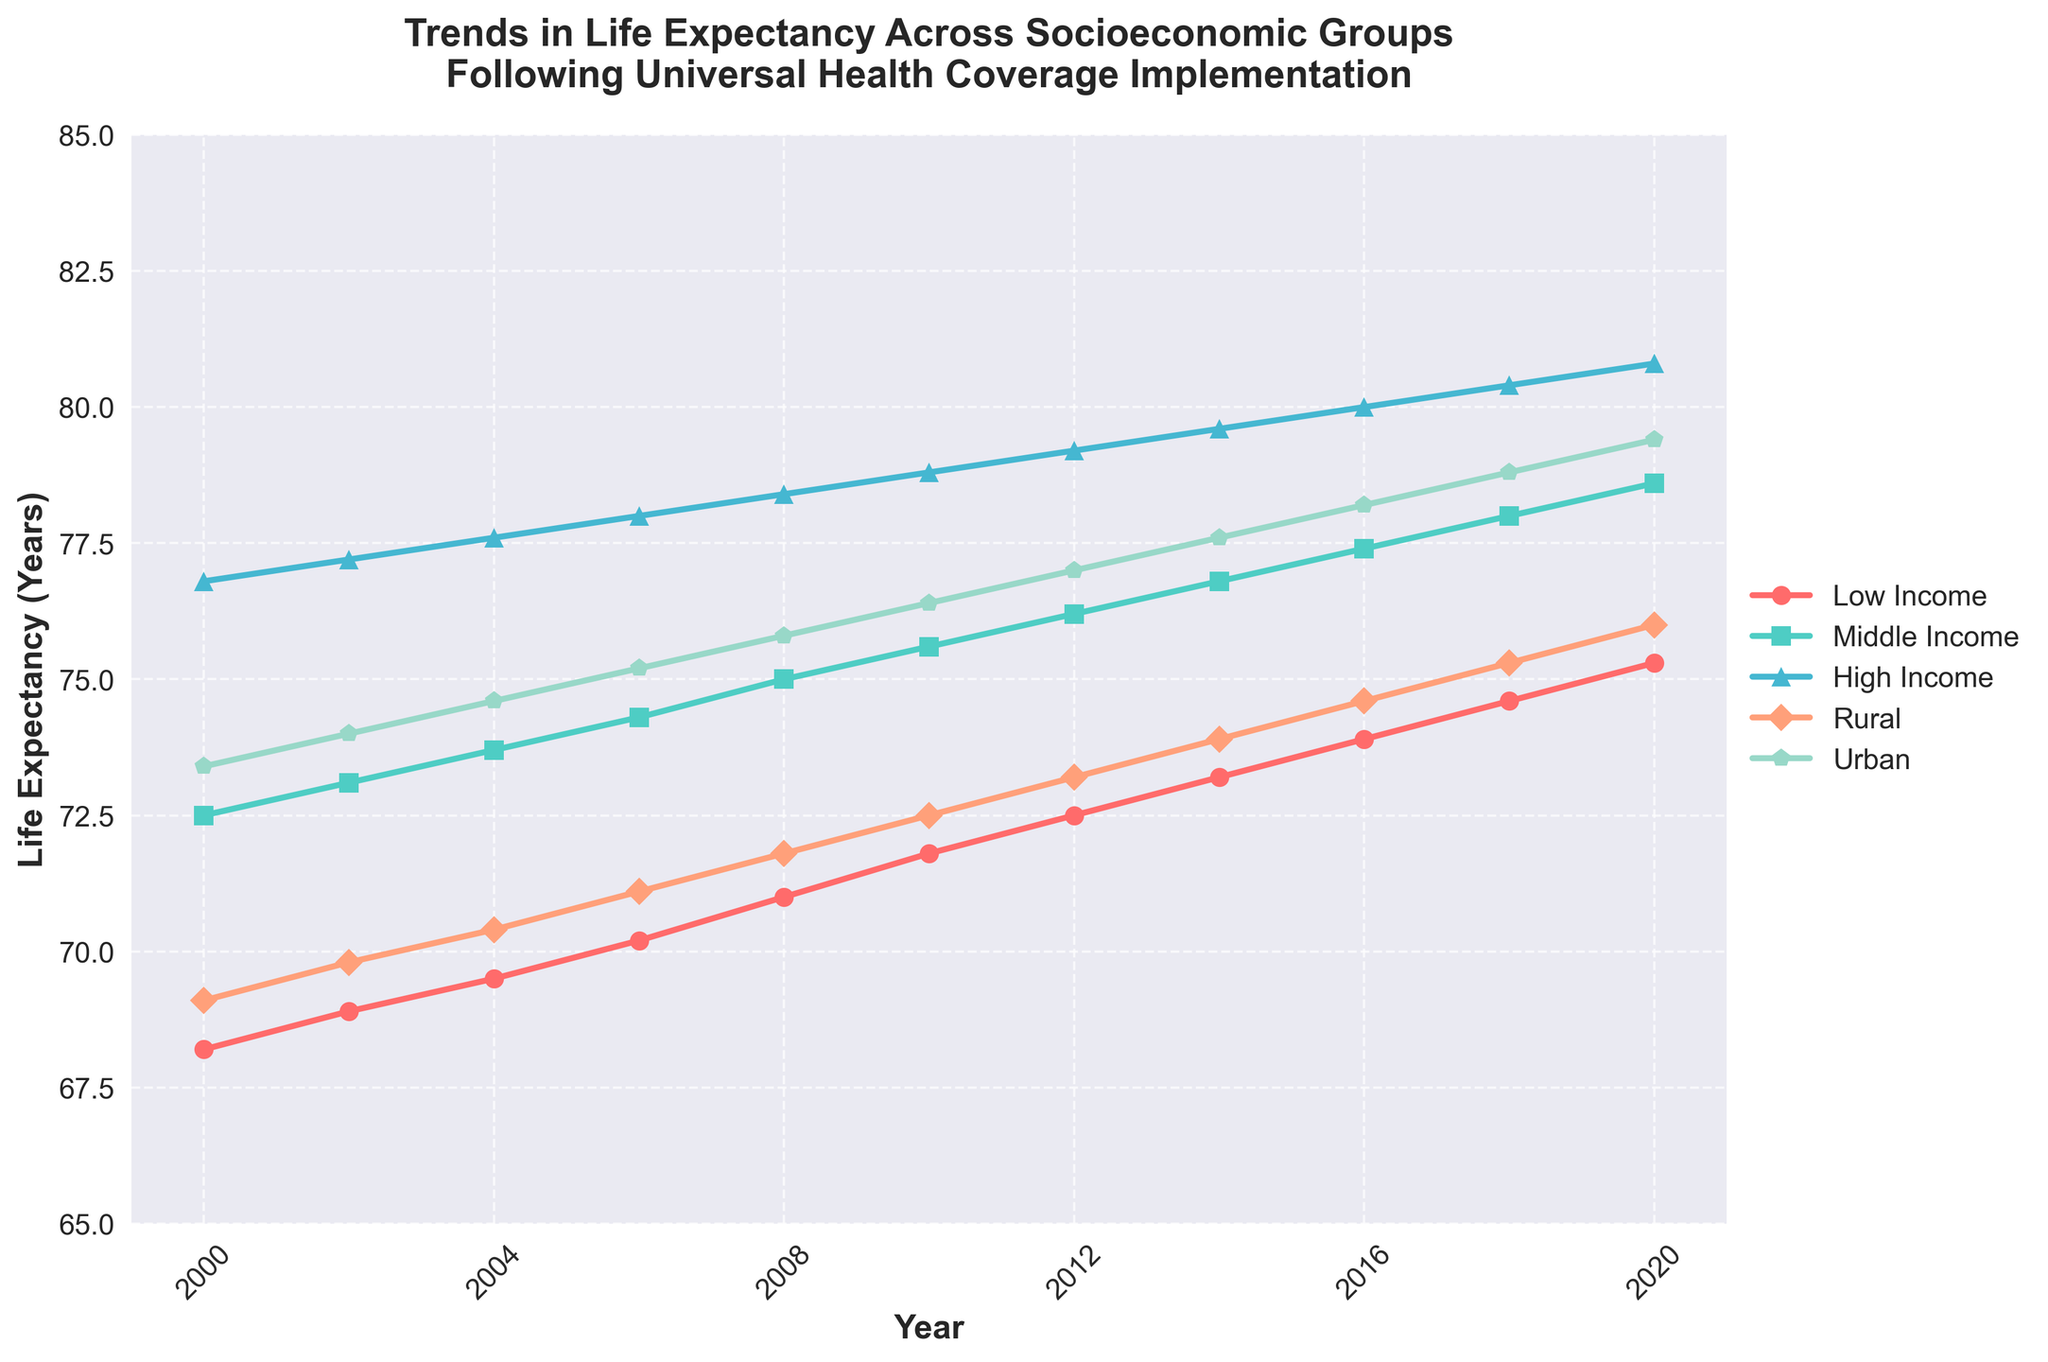What is the life expectancy difference between Rural and Urban areas in the year 2000? Identify the values for Rural (69.1) and Urban (73.4) life expectancies from the figure, then subtract Rural from Urban: 73.4 - 69.1 = 4.3
Answer: 4.3 Which group shows the highest increase in life expectancy between 2000 and 2020? Note the initial and final life expectancy values for each group, then calculate the difference for each: Low Income (75.3 - 68.2 = 7.1), Middle Income (78.6 - 72.5 = 6.1), High Income (80.8 - 76.8 = 4.0), Rural (76.0 - 69.1 = 6.9), Urban (79.4 - 73.4 = 6.0). The highest increase is for Low Income (7.1).
Answer: Low Income What is the average life expectancy of the Rural group across all the years shown? Sum all the values for the Rural group and divide by the number of values: (69.1 + 69.8 + 70.4 + 71.1 + 71.8 + 72.5 + 73.2 + 73.9 + 74.6 + 75.3 + 76.0) / 11 = 71.88
Answer: 71.88 How does the life expectancy of the Middle Income group compare to the High Income group in 2010? Identify and compare the values for 2010: Middle Income (75.6), High Income (78.8). Middle Income < High Income
Answer: High Income > Middle Income What trend can be observed in the life expectancy of the Middle Income group over the years? Observe that the Middle Income group's life expectancy consistently increases from 72.5 in 2000 to 78.6 in 2020. This indicates an upward trend throughout the observed period.
Answer: Upward trend 